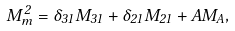Convert formula to latex. <formula><loc_0><loc_0><loc_500><loc_500>M _ { m } ^ { 2 } = \delta _ { 3 1 } M _ { 3 1 } + \delta _ { 2 1 } M _ { 2 1 } + A M _ { A } ,</formula> 